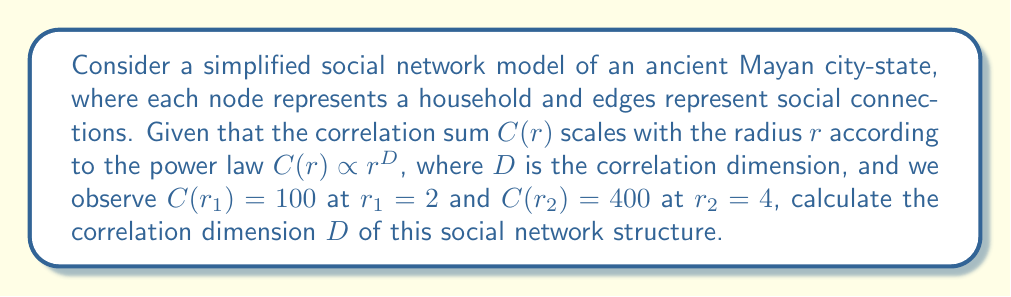Teach me how to tackle this problem. To solve this problem, we'll follow these steps:

1) The correlation sum follows the power law:
   $$C(r) \propto r^D$$

2) This means we can write:
   $$C(r) = kr^D$$
   where $k$ is a constant.

3) We have two data points:
   $$C(r_1) = 100$$ when $$r_1 = 2$$
   $$C(r_2) = 400$$ when $$r_2 = 4$$

4) We can write two equations:
   $$100 = k(2^D)$$
   $$400 = k(4^D)$$

5) Dividing the second equation by the first:
   $$\frac{400}{100} = \frac{k(4^D)}{k(2^D)}$$

6) The $k$ cancels out:
   $$4 = \frac{4^D}{2^D} = (2^D)^2 = 2^{2D}$$

7) Taking the logarithm of both sides:
   $$\log_2 4 = \log_2 2^{2D}$$

8) Simplify:
   $$2 = 2D$$

9) Solve for $D$:
   $$D = 1$$

This correlation dimension suggests that the social network structure in this ancient Mayan city-state exhibits characteristics similar to a linear system, which could indicate a hierarchical or chain-like social structure.
Answer: $D = 1$ 